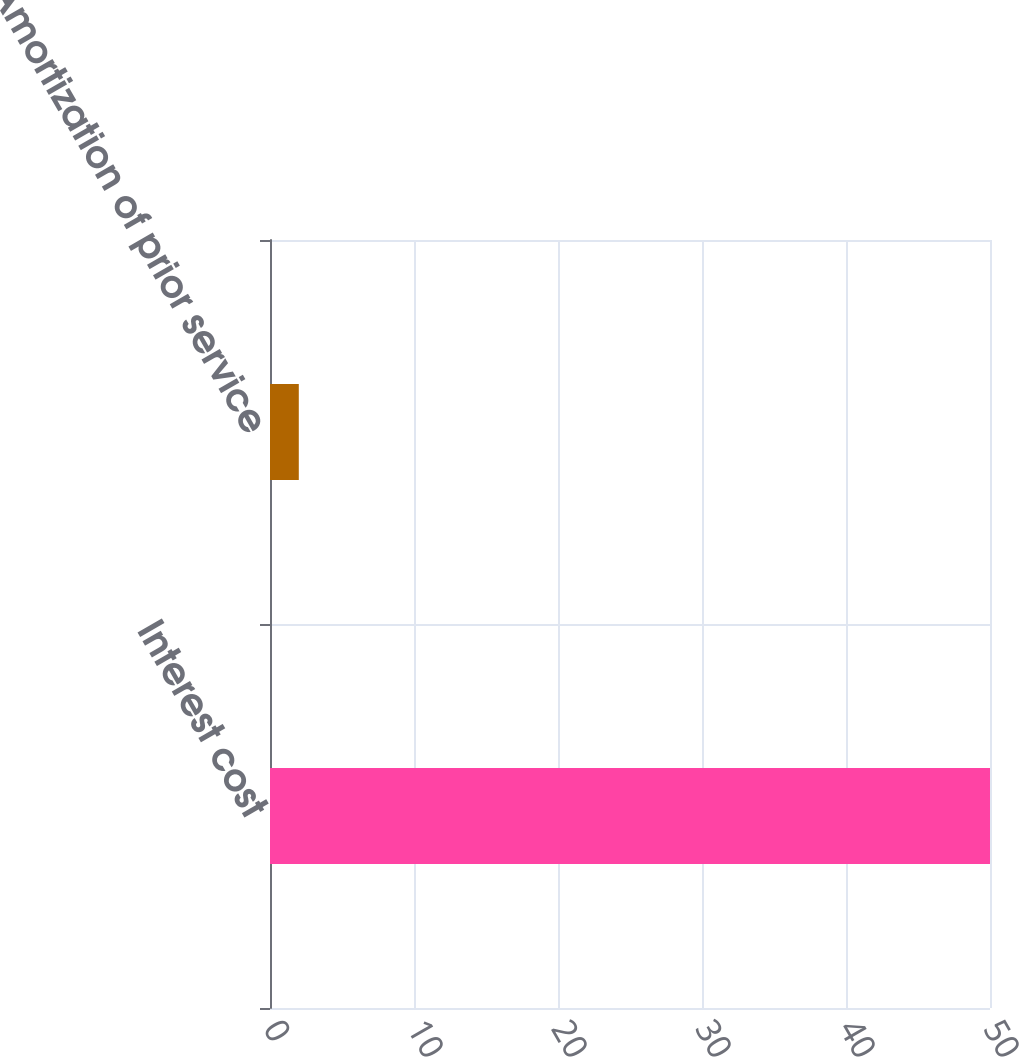<chart> <loc_0><loc_0><loc_500><loc_500><bar_chart><fcel>Interest cost<fcel>Amortization of prior service<nl><fcel>50<fcel>2<nl></chart> 